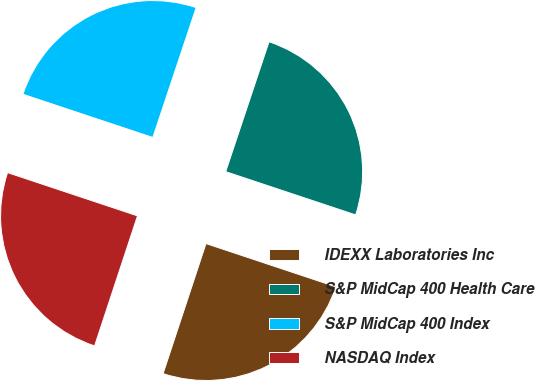Convert chart to OTSL. <chart><loc_0><loc_0><loc_500><loc_500><pie_chart><fcel>IDEXX Laboratories Inc<fcel>S&P MidCap 400 Health Care<fcel>S&P MidCap 400 Index<fcel>NASDAQ Index<nl><fcel>24.96%<fcel>24.99%<fcel>25.01%<fcel>25.04%<nl></chart> 